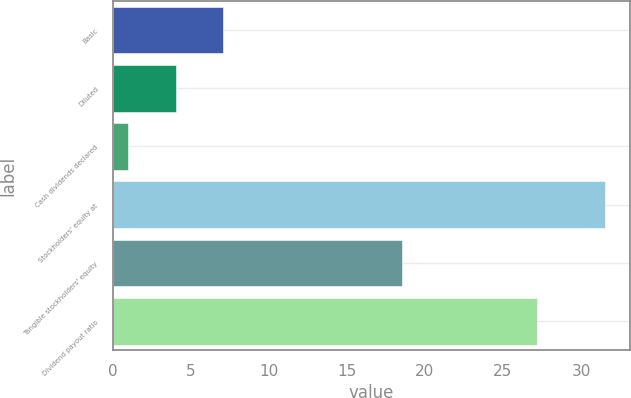Convert chart to OTSL. <chart><loc_0><loc_0><loc_500><loc_500><bar_chart><fcel>Basic<fcel>Diluted<fcel>Cash dividends declared<fcel>Stockholders' equity at<fcel>Tangible stockholders' equity<fcel>Dividend payout ratio<nl><fcel>7.1<fcel>4.05<fcel>1<fcel>31.54<fcel>18.54<fcel>27.19<nl></chart> 